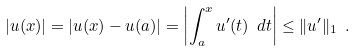<formula> <loc_0><loc_0><loc_500><loc_500>| u ( x ) | = | u ( x ) - u ( a ) | = \left | \int _ { a } ^ { x } u ^ { \prime } ( t ) \ d t \right | \leq \| u ^ { \prime } \| _ { 1 } \ .</formula> 